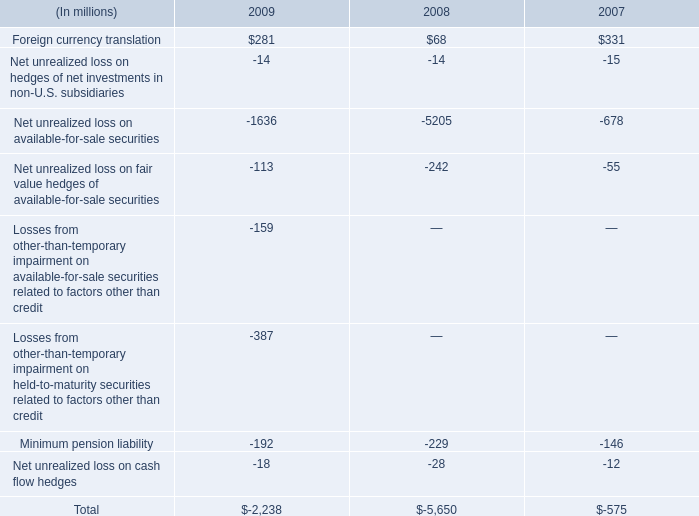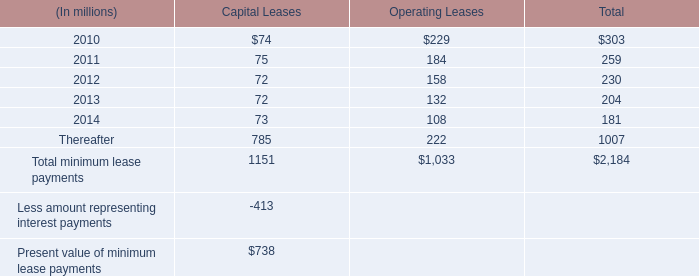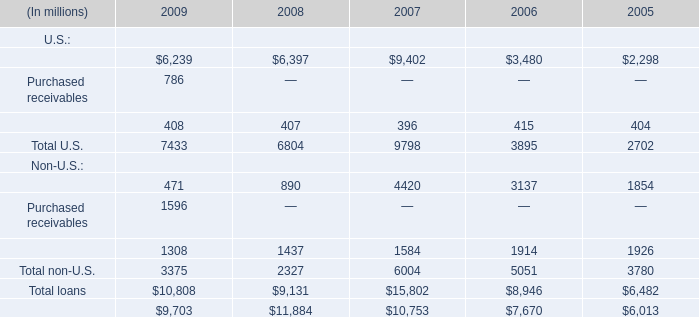What's the 30% of total Non-U.S. in 2009? (in million) 
Computations: (3375 * 0.3)
Answer: 1012.5. 